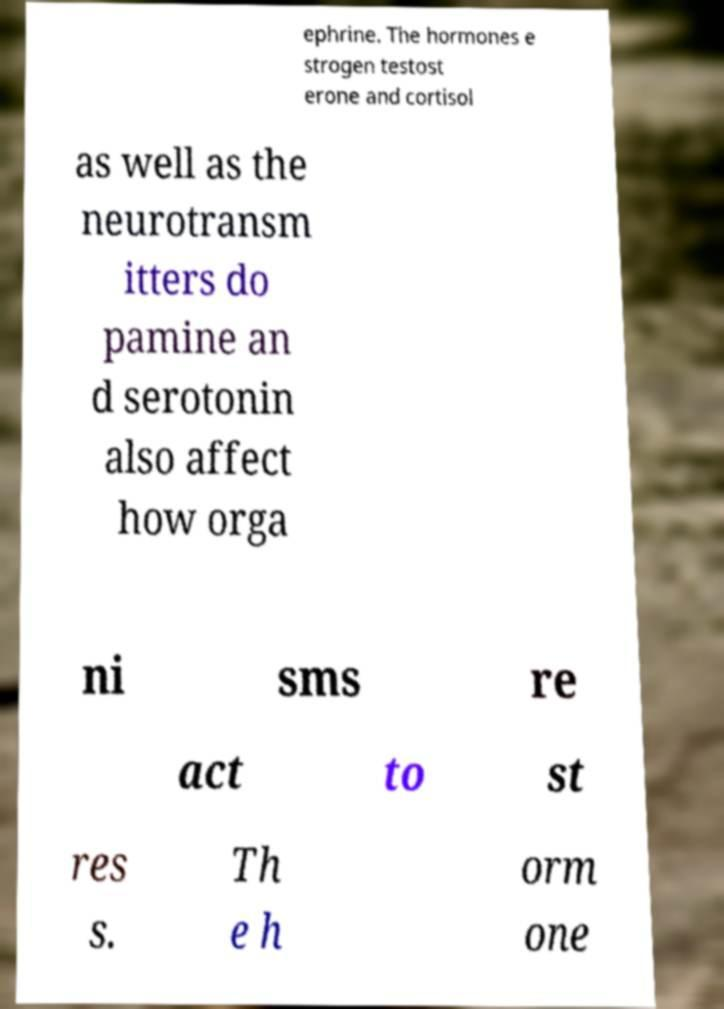I need the written content from this picture converted into text. Can you do that? ephrine. The hormones e strogen testost erone and cortisol as well as the neurotransm itters do pamine an d serotonin also affect how orga ni sms re act to st res s. Th e h orm one 